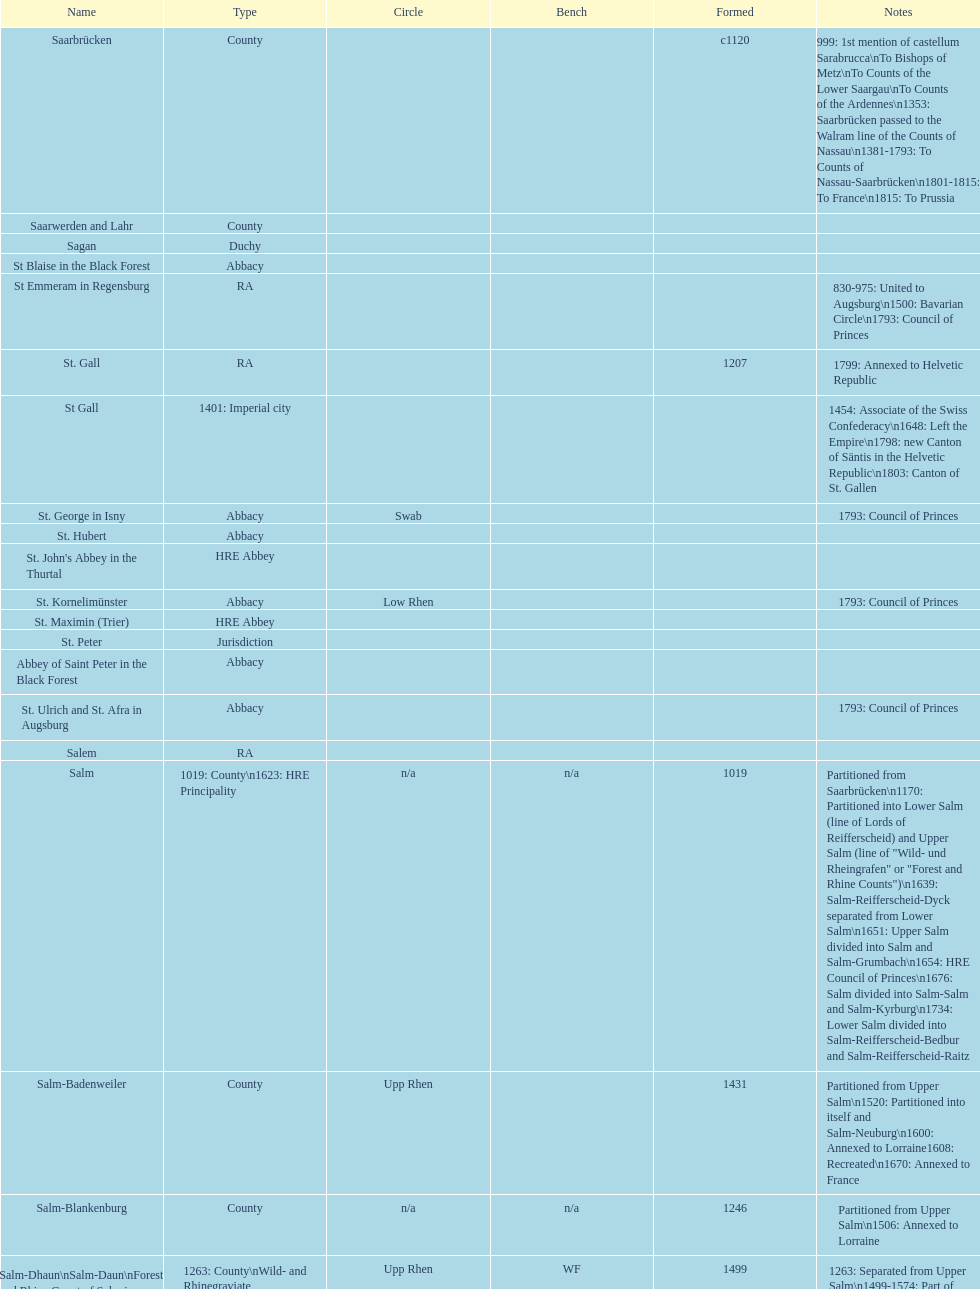How many states were of the same kind as stühlingen? 3. 